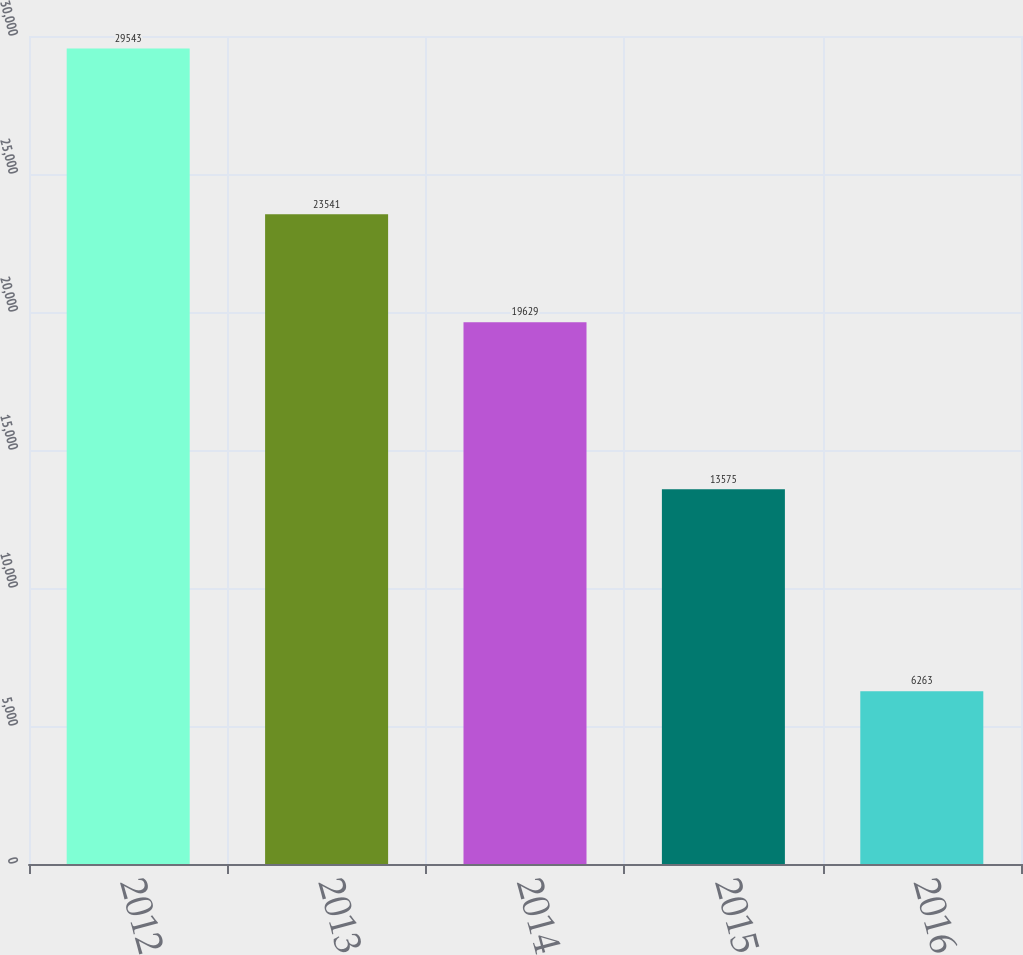<chart> <loc_0><loc_0><loc_500><loc_500><bar_chart><fcel>2012<fcel>2013<fcel>2014<fcel>2015<fcel>2016<nl><fcel>29543<fcel>23541<fcel>19629<fcel>13575<fcel>6263<nl></chart> 